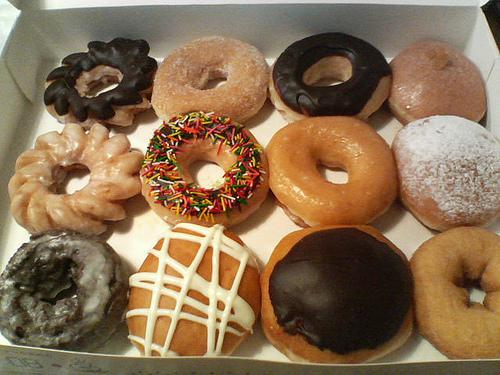Question: where are the donuts?
Choices:
A. In a box.
B. On the table.
C. On a plate.
D. In his mouth.
Answer with the letter. Answer: A Question: how many chocolate covered donuts are there?
Choices:
A. Three.
B. Four.
C. Five.
D. Two.
Answer with the letter. Answer: A Question: how many donuts are there in the box?
Choices:
A. Ten.
B. Five.
C. Six.
D. Twelve.
Answer with the letter. Answer: D 